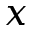Convert formula to latex. <formula><loc_0><loc_0><loc_500><loc_500>x</formula> 